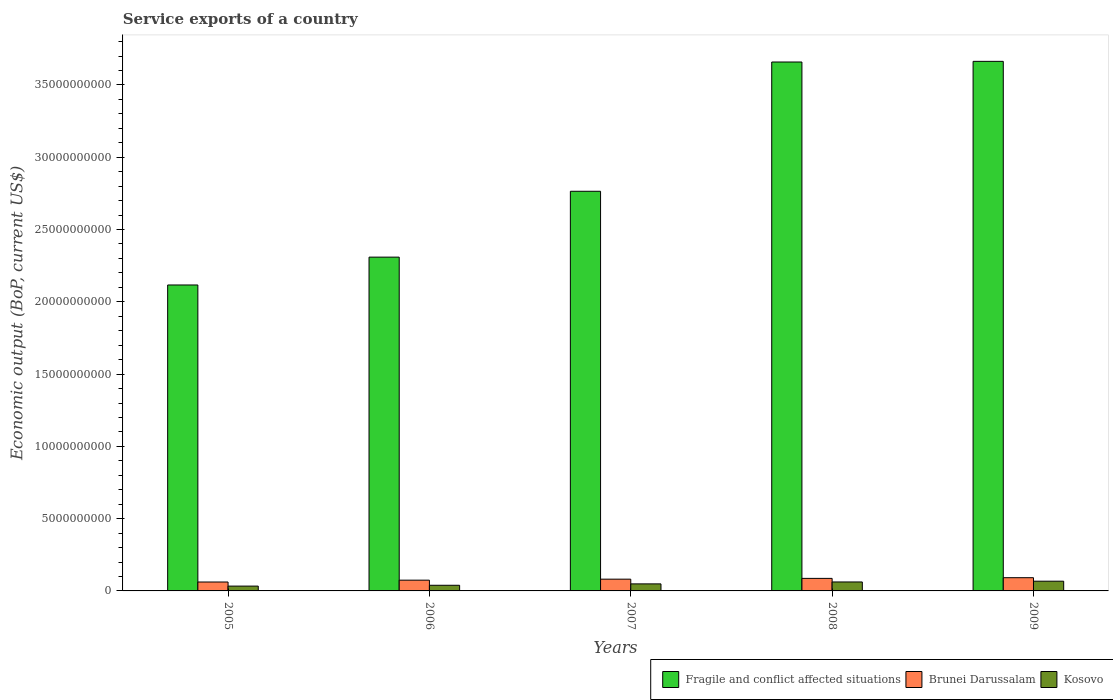How many different coloured bars are there?
Ensure brevity in your answer.  3. How many groups of bars are there?
Offer a terse response. 5. How many bars are there on the 5th tick from the right?
Your answer should be compact. 3. What is the label of the 3rd group of bars from the left?
Make the answer very short. 2007. What is the service exports in Brunei Darussalam in 2006?
Your answer should be very brief. 7.45e+08. Across all years, what is the maximum service exports in Kosovo?
Ensure brevity in your answer.  6.73e+08. Across all years, what is the minimum service exports in Fragile and conflict affected situations?
Offer a very short reply. 2.12e+1. In which year was the service exports in Brunei Darussalam maximum?
Your answer should be very brief. 2009. In which year was the service exports in Fragile and conflict affected situations minimum?
Make the answer very short. 2005. What is the total service exports in Fragile and conflict affected situations in the graph?
Make the answer very short. 1.45e+11. What is the difference between the service exports in Fragile and conflict affected situations in 2006 and that in 2009?
Make the answer very short. -1.35e+1. What is the difference between the service exports in Brunei Darussalam in 2007 and the service exports in Kosovo in 2008?
Provide a succinct answer. 1.93e+08. What is the average service exports in Brunei Darussalam per year?
Your answer should be compact. 7.91e+08. In the year 2007, what is the difference between the service exports in Fragile and conflict affected situations and service exports in Kosovo?
Make the answer very short. 2.72e+1. In how many years, is the service exports in Fragile and conflict affected situations greater than 28000000000 US$?
Provide a succinct answer. 2. What is the ratio of the service exports in Brunei Darussalam in 2006 to that in 2008?
Your answer should be compact. 0.86. Is the service exports in Kosovo in 2005 less than that in 2006?
Your answer should be compact. Yes. Is the difference between the service exports in Fragile and conflict affected situations in 2008 and 2009 greater than the difference between the service exports in Kosovo in 2008 and 2009?
Make the answer very short. Yes. What is the difference between the highest and the second highest service exports in Kosovo?
Your response must be concise. 5.27e+07. What is the difference between the highest and the lowest service exports in Kosovo?
Keep it short and to the point. 3.40e+08. What does the 2nd bar from the left in 2005 represents?
Give a very brief answer. Brunei Darussalam. What does the 2nd bar from the right in 2009 represents?
Your answer should be compact. Brunei Darussalam. How many bars are there?
Your answer should be very brief. 15. Are all the bars in the graph horizontal?
Your answer should be compact. No. How many years are there in the graph?
Offer a terse response. 5. Does the graph contain any zero values?
Offer a terse response. No. Does the graph contain grids?
Offer a terse response. No. How many legend labels are there?
Ensure brevity in your answer.  3. What is the title of the graph?
Give a very brief answer. Service exports of a country. What is the label or title of the Y-axis?
Give a very brief answer. Economic output (BoP, current US$). What is the Economic output (BoP, current US$) in Fragile and conflict affected situations in 2005?
Offer a terse response. 2.12e+1. What is the Economic output (BoP, current US$) in Brunei Darussalam in 2005?
Your response must be concise. 6.16e+08. What is the Economic output (BoP, current US$) of Kosovo in 2005?
Your answer should be compact. 3.33e+08. What is the Economic output (BoP, current US$) of Fragile and conflict affected situations in 2006?
Ensure brevity in your answer.  2.31e+1. What is the Economic output (BoP, current US$) of Brunei Darussalam in 2006?
Give a very brief answer. 7.45e+08. What is the Economic output (BoP, current US$) in Kosovo in 2006?
Offer a terse response. 3.91e+08. What is the Economic output (BoP, current US$) of Fragile and conflict affected situations in 2007?
Offer a terse response. 2.76e+1. What is the Economic output (BoP, current US$) of Brunei Darussalam in 2007?
Make the answer very short. 8.13e+08. What is the Economic output (BoP, current US$) in Kosovo in 2007?
Your response must be concise. 4.86e+08. What is the Economic output (BoP, current US$) of Fragile and conflict affected situations in 2008?
Offer a very short reply. 3.66e+1. What is the Economic output (BoP, current US$) in Brunei Darussalam in 2008?
Give a very brief answer. 8.67e+08. What is the Economic output (BoP, current US$) of Kosovo in 2008?
Your response must be concise. 6.20e+08. What is the Economic output (BoP, current US$) in Fragile and conflict affected situations in 2009?
Ensure brevity in your answer.  3.66e+1. What is the Economic output (BoP, current US$) of Brunei Darussalam in 2009?
Offer a terse response. 9.15e+08. What is the Economic output (BoP, current US$) of Kosovo in 2009?
Ensure brevity in your answer.  6.73e+08. Across all years, what is the maximum Economic output (BoP, current US$) of Fragile and conflict affected situations?
Your answer should be very brief. 3.66e+1. Across all years, what is the maximum Economic output (BoP, current US$) of Brunei Darussalam?
Give a very brief answer. 9.15e+08. Across all years, what is the maximum Economic output (BoP, current US$) in Kosovo?
Offer a terse response. 6.73e+08. Across all years, what is the minimum Economic output (BoP, current US$) in Fragile and conflict affected situations?
Make the answer very short. 2.12e+1. Across all years, what is the minimum Economic output (BoP, current US$) in Brunei Darussalam?
Make the answer very short. 6.16e+08. Across all years, what is the minimum Economic output (BoP, current US$) of Kosovo?
Provide a short and direct response. 3.33e+08. What is the total Economic output (BoP, current US$) of Fragile and conflict affected situations in the graph?
Offer a very short reply. 1.45e+11. What is the total Economic output (BoP, current US$) of Brunei Darussalam in the graph?
Your response must be concise. 3.96e+09. What is the total Economic output (BoP, current US$) of Kosovo in the graph?
Ensure brevity in your answer.  2.50e+09. What is the difference between the Economic output (BoP, current US$) in Fragile and conflict affected situations in 2005 and that in 2006?
Your response must be concise. -1.93e+09. What is the difference between the Economic output (BoP, current US$) in Brunei Darussalam in 2005 and that in 2006?
Provide a short and direct response. -1.28e+08. What is the difference between the Economic output (BoP, current US$) in Kosovo in 2005 and that in 2006?
Keep it short and to the point. -5.80e+07. What is the difference between the Economic output (BoP, current US$) of Fragile and conflict affected situations in 2005 and that in 2007?
Offer a very short reply. -6.48e+09. What is the difference between the Economic output (BoP, current US$) in Brunei Darussalam in 2005 and that in 2007?
Your answer should be compact. -1.97e+08. What is the difference between the Economic output (BoP, current US$) in Kosovo in 2005 and that in 2007?
Your response must be concise. -1.53e+08. What is the difference between the Economic output (BoP, current US$) in Fragile and conflict affected situations in 2005 and that in 2008?
Keep it short and to the point. -1.54e+1. What is the difference between the Economic output (BoP, current US$) of Brunei Darussalam in 2005 and that in 2008?
Make the answer very short. -2.51e+08. What is the difference between the Economic output (BoP, current US$) of Kosovo in 2005 and that in 2008?
Provide a succinct answer. -2.87e+08. What is the difference between the Economic output (BoP, current US$) in Fragile and conflict affected situations in 2005 and that in 2009?
Your answer should be compact. -1.55e+1. What is the difference between the Economic output (BoP, current US$) in Brunei Darussalam in 2005 and that in 2009?
Your answer should be compact. -2.99e+08. What is the difference between the Economic output (BoP, current US$) in Kosovo in 2005 and that in 2009?
Your response must be concise. -3.40e+08. What is the difference between the Economic output (BoP, current US$) in Fragile and conflict affected situations in 2006 and that in 2007?
Give a very brief answer. -4.56e+09. What is the difference between the Economic output (BoP, current US$) in Brunei Darussalam in 2006 and that in 2007?
Offer a terse response. -6.88e+07. What is the difference between the Economic output (BoP, current US$) of Kosovo in 2006 and that in 2007?
Give a very brief answer. -9.52e+07. What is the difference between the Economic output (BoP, current US$) of Fragile and conflict affected situations in 2006 and that in 2008?
Offer a terse response. -1.35e+1. What is the difference between the Economic output (BoP, current US$) of Brunei Darussalam in 2006 and that in 2008?
Offer a terse response. -1.23e+08. What is the difference between the Economic output (BoP, current US$) in Kosovo in 2006 and that in 2008?
Provide a short and direct response. -2.29e+08. What is the difference between the Economic output (BoP, current US$) in Fragile and conflict affected situations in 2006 and that in 2009?
Provide a short and direct response. -1.35e+1. What is the difference between the Economic output (BoP, current US$) in Brunei Darussalam in 2006 and that in 2009?
Keep it short and to the point. -1.70e+08. What is the difference between the Economic output (BoP, current US$) of Kosovo in 2006 and that in 2009?
Provide a succinct answer. -2.82e+08. What is the difference between the Economic output (BoP, current US$) in Fragile and conflict affected situations in 2007 and that in 2008?
Your response must be concise. -8.94e+09. What is the difference between the Economic output (BoP, current US$) of Brunei Darussalam in 2007 and that in 2008?
Keep it short and to the point. -5.39e+07. What is the difference between the Economic output (BoP, current US$) of Kosovo in 2007 and that in 2008?
Your answer should be compact. -1.34e+08. What is the difference between the Economic output (BoP, current US$) in Fragile and conflict affected situations in 2007 and that in 2009?
Provide a succinct answer. -8.99e+09. What is the difference between the Economic output (BoP, current US$) of Brunei Darussalam in 2007 and that in 2009?
Offer a terse response. -1.02e+08. What is the difference between the Economic output (BoP, current US$) of Kosovo in 2007 and that in 2009?
Your answer should be compact. -1.87e+08. What is the difference between the Economic output (BoP, current US$) of Fragile and conflict affected situations in 2008 and that in 2009?
Make the answer very short. -4.49e+07. What is the difference between the Economic output (BoP, current US$) of Brunei Darussalam in 2008 and that in 2009?
Your answer should be compact. -4.77e+07. What is the difference between the Economic output (BoP, current US$) of Kosovo in 2008 and that in 2009?
Your answer should be compact. -5.27e+07. What is the difference between the Economic output (BoP, current US$) in Fragile and conflict affected situations in 2005 and the Economic output (BoP, current US$) in Brunei Darussalam in 2006?
Make the answer very short. 2.04e+1. What is the difference between the Economic output (BoP, current US$) of Fragile and conflict affected situations in 2005 and the Economic output (BoP, current US$) of Kosovo in 2006?
Your response must be concise. 2.08e+1. What is the difference between the Economic output (BoP, current US$) of Brunei Darussalam in 2005 and the Economic output (BoP, current US$) of Kosovo in 2006?
Keep it short and to the point. 2.25e+08. What is the difference between the Economic output (BoP, current US$) of Fragile and conflict affected situations in 2005 and the Economic output (BoP, current US$) of Brunei Darussalam in 2007?
Offer a terse response. 2.04e+1. What is the difference between the Economic output (BoP, current US$) in Fragile and conflict affected situations in 2005 and the Economic output (BoP, current US$) in Kosovo in 2007?
Your response must be concise. 2.07e+1. What is the difference between the Economic output (BoP, current US$) of Brunei Darussalam in 2005 and the Economic output (BoP, current US$) of Kosovo in 2007?
Your answer should be compact. 1.30e+08. What is the difference between the Economic output (BoP, current US$) in Fragile and conflict affected situations in 2005 and the Economic output (BoP, current US$) in Brunei Darussalam in 2008?
Ensure brevity in your answer.  2.03e+1. What is the difference between the Economic output (BoP, current US$) in Fragile and conflict affected situations in 2005 and the Economic output (BoP, current US$) in Kosovo in 2008?
Your answer should be very brief. 2.05e+1. What is the difference between the Economic output (BoP, current US$) in Brunei Darussalam in 2005 and the Economic output (BoP, current US$) in Kosovo in 2008?
Your answer should be very brief. -4.17e+06. What is the difference between the Economic output (BoP, current US$) in Fragile and conflict affected situations in 2005 and the Economic output (BoP, current US$) in Brunei Darussalam in 2009?
Your answer should be very brief. 2.03e+1. What is the difference between the Economic output (BoP, current US$) of Fragile and conflict affected situations in 2005 and the Economic output (BoP, current US$) of Kosovo in 2009?
Your response must be concise. 2.05e+1. What is the difference between the Economic output (BoP, current US$) in Brunei Darussalam in 2005 and the Economic output (BoP, current US$) in Kosovo in 2009?
Make the answer very short. -5.69e+07. What is the difference between the Economic output (BoP, current US$) of Fragile and conflict affected situations in 2006 and the Economic output (BoP, current US$) of Brunei Darussalam in 2007?
Provide a short and direct response. 2.23e+1. What is the difference between the Economic output (BoP, current US$) of Fragile and conflict affected situations in 2006 and the Economic output (BoP, current US$) of Kosovo in 2007?
Your response must be concise. 2.26e+1. What is the difference between the Economic output (BoP, current US$) of Brunei Darussalam in 2006 and the Economic output (BoP, current US$) of Kosovo in 2007?
Ensure brevity in your answer.  2.58e+08. What is the difference between the Economic output (BoP, current US$) in Fragile and conflict affected situations in 2006 and the Economic output (BoP, current US$) in Brunei Darussalam in 2008?
Ensure brevity in your answer.  2.22e+1. What is the difference between the Economic output (BoP, current US$) in Fragile and conflict affected situations in 2006 and the Economic output (BoP, current US$) in Kosovo in 2008?
Make the answer very short. 2.25e+1. What is the difference between the Economic output (BoP, current US$) of Brunei Darussalam in 2006 and the Economic output (BoP, current US$) of Kosovo in 2008?
Your answer should be very brief. 1.24e+08. What is the difference between the Economic output (BoP, current US$) of Fragile and conflict affected situations in 2006 and the Economic output (BoP, current US$) of Brunei Darussalam in 2009?
Make the answer very short. 2.22e+1. What is the difference between the Economic output (BoP, current US$) in Fragile and conflict affected situations in 2006 and the Economic output (BoP, current US$) in Kosovo in 2009?
Offer a very short reply. 2.24e+1. What is the difference between the Economic output (BoP, current US$) in Brunei Darussalam in 2006 and the Economic output (BoP, current US$) in Kosovo in 2009?
Your answer should be compact. 7.15e+07. What is the difference between the Economic output (BoP, current US$) of Fragile and conflict affected situations in 2007 and the Economic output (BoP, current US$) of Brunei Darussalam in 2008?
Offer a very short reply. 2.68e+1. What is the difference between the Economic output (BoP, current US$) of Fragile and conflict affected situations in 2007 and the Economic output (BoP, current US$) of Kosovo in 2008?
Your answer should be compact. 2.70e+1. What is the difference between the Economic output (BoP, current US$) in Brunei Darussalam in 2007 and the Economic output (BoP, current US$) in Kosovo in 2008?
Offer a very short reply. 1.93e+08. What is the difference between the Economic output (BoP, current US$) in Fragile and conflict affected situations in 2007 and the Economic output (BoP, current US$) in Brunei Darussalam in 2009?
Provide a short and direct response. 2.67e+1. What is the difference between the Economic output (BoP, current US$) in Fragile and conflict affected situations in 2007 and the Economic output (BoP, current US$) in Kosovo in 2009?
Ensure brevity in your answer.  2.70e+1. What is the difference between the Economic output (BoP, current US$) of Brunei Darussalam in 2007 and the Economic output (BoP, current US$) of Kosovo in 2009?
Provide a succinct answer. 1.40e+08. What is the difference between the Economic output (BoP, current US$) in Fragile and conflict affected situations in 2008 and the Economic output (BoP, current US$) in Brunei Darussalam in 2009?
Ensure brevity in your answer.  3.57e+1. What is the difference between the Economic output (BoP, current US$) of Fragile and conflict affected situations in 2008 and the Economic output (BoP, current US$) of Kosovo in 2009?
Your response must be concise. 3.59e+1. What is the difference between the Economic output (BoP, current US$) in Brunei Darussalam in 2008 and the Economic output (BoP, current US$) in Kosovo in 2009?
Your response must be concise. 1.94e+08. What is the average Economic output (BoP, current US$) of Fragile and conflict affected situations per year?
Offer a very short reply. 2.90e+1. What is the average Economic output (BoP, current US$) in Brunei Darussalam per year?
Provide a short and direct response. 7.91e+08. What is the average Economic output (BoP, current US$) of Kosovo per year?
Your answer should be compact. 5.01e+08. In the year 2005, what is the difference between the Economic output (BoP, current US$) in Fragile and conflict affected situations and Economic output (BoP, current US$) in Brunei Darussalam?
Keep it short and to the point. 2.05e+1. In the year 2005, what is the difference between the Economic output (BoP, current US$) of Fragile and conflict affected situations and Economic output (BoP, current US$) of Kosovo?
Keep it short and to the point. 2.08e+1. In the year 2005, what is the difference between the Economic output (BoP, current US$) in Brunei Darussalam and Economic output (BoP, current US$) in Kosovo?
Offer a very short reply. 2.83e+08. In the year 2006, what is the difference between the Economic output (BoP, current US$) in Fragile and conflict affected situations and Economic output (BoP, current US$) in Brunei Darussalam?
Your answer should be very brief. 2.23e+1. In the year 2006, what is the difference between the Economic output (BoP, current US$) of Fragile and conflict affected situations and Economic output (BoP, current US$) of Kosovo?
Ensure brevity in your answer.  2.27e+1. In the year 2006, what is the difference between the Economic output (BoP, current US$) of Brunei Darussalam and Economic output (BoP, current US$) of Kosovo?
Your answer should be compact. 3.53e+08. In the year 2007, what is the difference between the Economic output (BoP, current US$) in Fragile and conflict affected situations and Economic output (BoP, current US$) in Brunei Darussalam?
Provide a succinct answer. 2.68e+1. In the year 2007, what is the difference between the Economic output (BoP, current US$) of Fragile and conflict affected situations and Economic output (BoP, current US$) of Kosovo?
Provide a succinct answer. 2.72e+1. In the year 2007, what is the difference between the Economic output (BoP, current US$) in Brunei Darussalam and Economic output (BoP, current US$) in Kosovo?
Keep it short and to the point. 3.27e+08. In the year 2008, what is the difference between the Economic output (BoP, current US$) of Fragile and conflict affected situations and Economic output (BoP, current US$) of Brunei Darussalam?
Provide a short and direct response. 3.57e+1. In the year 2008, what is the difference between the Economic output (BoP, current US$) of Fragile and conflict affected situations and Economic output (BoP, current US$) of Kosovo?
Provide a succinct answer. 3.60e+1. In the year 2008, what is the difference between the Economic output (BoP, current US$) of Brunei Darussalam and Economic output (BoP, current US$) of Kosovo?
Provide a short and direct response. 2.47e+08. In the year 2009, what is the difference between the Economic output (BoP, current US$) in Fragile and conflict affected situations and Economic output (BoP, current US$) in Brunei Darussalam?
Your response must be concise. 3.57e+1. In the year 2009, what is the difference between the Economic output (BoP, current US$) in Fragile and conflict affected situations and Economic output (BoP, current US$) in Kosovo?
Ensure brevity in your answer.  3.60e+1. In the year 2009, what is the difference between the Economic output (BoP, current US$) of Brunei Darussalam and Economic output (BoP, current US$) of Kosovo?
Keep it short and to the point. 2.42e+08. What is the ratio of the Economic output (BoP, current US$) in Fragile and conflict affected situations in 2005 to that in 2006?
Keep it short and to the point. 0.92. What is the ratio of the Economic output (BoP, current US$) in Brunei Darussalam in 2005 to that in 2006?
Provide a succinct answer. 0.83. What is the ratio of the Economic output (BoP, current US$) in Kosovo in 2005 to that in 2006?
Provide a short and direct response. 0.85. What is the ratio of the Economic output (BoP, current US$) in Fragile and conflict affected situations in 2005 to that in 2007?
Your answer should be compact. 0.77. What is the ratio of the Economic output (BoP, current US$) in Brunei Darussalam in 2005 to that in 2007?
Your answer should be very brief. 0.76. What is the ratio of the Economic output (BoP, current US$) in Kosovo in 2005 to that in 2007?
Your answer should be very brief. 0.68. What is the ratio of the Economic output (BoP, current US$) of Fragile and conflict affected situations in 2005 to that in 2008?
Your response must be concise. 0.58. What is the ratio of the Economic output (BoP, current US$) of Brunei Darussalam in 2005 to that in 2008?
Your answer should be compact. 0.71. What is the ratio of the Economic output (BoP, current US$) in Kosovo in 2005 to that in 2008?
Provide a short and direct response. 0.54. What is the ratio of the Economic output (BoP, current US$) of Fragile and conflict affected situations in 2005 to that in 2009?
Provide a short and direct response. 0.58. What is the ratio of the Economic output (BoP, current US$) of Brunei Darussalam in 2005 to that in 2009?
Your response must be concise. 0.67. What is the ratio of the Economic output (BoP, current US$) in Kosovo in 2005 to that in 2009?
Offer a very short reply. 0.5. What is the ratio of the Economic output (BoP, current US$) of Fragile and conflict affected situations in 2006 to that in 2007?
Offer a terse response. 0.84. What is the ratio of the Economic output (BoP, current US$) in Brunei Darussalam in 2006 to that in 2007?
Your answer should be compact. 0.92. What is the ratio of the Economic output (BoP, current US$) of Kosovo in 2006 to that in 2007?
Make the answer very short. 0.8. What is the ratio of the Economic output (BoP, current US$) in Fragile and conflict affected situations in 2006 to that in 2008?
Offer a terse response. 0.63. What is the ratio of the Economic output (BoP, current US$) in Brunei Darussalam in 2006 to that in 2008?
Offer a terse response. 0.86. What is the ratio of the Economic output (BoP, current US$) of Kosovo in 2006 to that in 2008?
Your response must be concise. 0.63. What is the ratio of the Economic output (BoP, current US$) of Fragile and conflict affected situations in 2006 to that in 2009?
Your answer should be compact. 0.63. What is the ratio of the Economic output (BoP, current US$) in Brunei Darussalam in 2006 to that in 2009?
Make the answer very short. 0.81. What is the ratio of the Economic output (BoP, current US$) of Kosovo in 2006 to that in 2009?
Your answer should be compact. 0.58. What is the ratio of the Economic output (BoP, current US$) in Fragile and conflict affected situations in 2007 to that in 2008?
Ensure brevity in your answer.  0.76. What is the ratio of the Economic output (BoP, current US$) in Brunei Darussalam in 2007 to that in 2008?
Provide a short and direct response. 0.94. What is the ratio of the Economic output (BoP, current US$) in Kosovo in 2007 to that in 2008?
Keep it short and to the point. 0.78. What is the ratio of the Economic output (BoP, current US$) in Fragile and conflict affected situations in 2007 to that in 2009?
Ensure brevity in your answer.  0.75. What is the ratio of the Economic output (BoP, current US$) of Brunei Darussalam in 2007 to that in 2009?
Your answer should be compact. 0.89. What is the ratio of the Economic output (BoP, current US$) in Kosovo in 2007 to that in 2009?
Make the answer very short. 0.72. What is the ratio of the Economic output (BoP, current US$) in Brunei Darussalam in 2008 to that in 2009?
Your response must be concise. 0.95. What is the ratio of the Economic output (BoP, current US$) in Kosovo in 2008 to that in 2009?
Your answer should be compact. 0.92. What is the difference between the highest and the second highest Economic output (BoP, current US$) of Fragile and conflict affected situations?
Ensure brevity in your answer.  4.49e+07. What is the difference between the highest and the second highest Economic output (BoP, current US$) of Brunei Darussalam?
Your response must be concise. 4.77e+07. What is the difference between the highest and the second highest Economic output (BoP, current US$) in Kosovo?
Your answer should be very brief. 5.27e+07. What is the difference between the highest and the lowest Economic output (BoP, current US$) of Fragile and conflict affected situations?
Keep it short and to the point. 1.55e+1. What is the difference between the highest and the lowest Economic output (BoP, current US$) of Brunei Darussalam?
Make the answer very short. 2.99e+08. What is the difference between the highest and the lowest Economic output (BoP, current US$) in Kosovo?
Offer a very short reply. 3.40e+08. 